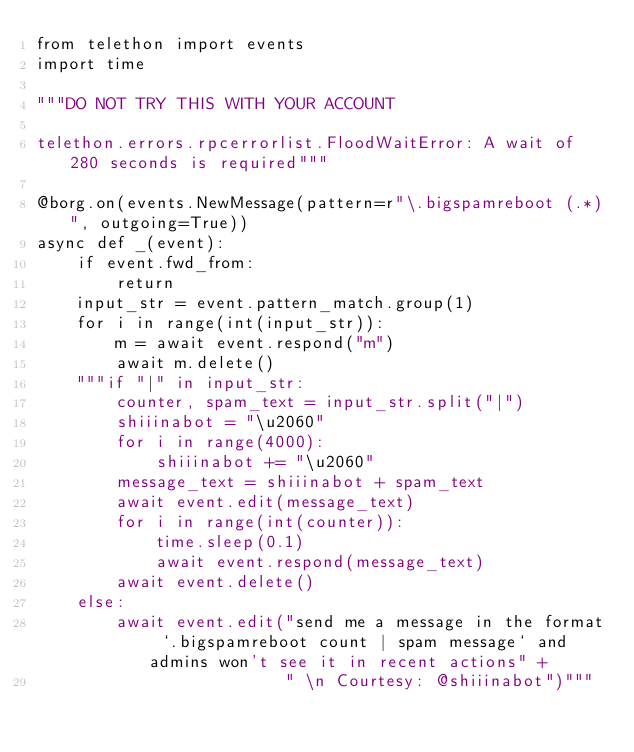<code> <loc_0><loc_0><loc_500><loc_500><_Python_>from telethon import events
import time

"""DO NOT TRY THIS WITH YOUR ACCOUNT

telethon.errors.rpcerrorlist.FloodWaitError: A wait of 280 seconds is required"""

@borg.on(events.NewMessage(pattern=r"\.bigspamreboot (.*)", outgoing=True))
async def _(event):
    if event.fwd_from:
        return
    input_str = event.pattern_match.group(1)
    for i in range(int(input_str)):
        m = await event.respond("m")
        await m.delete()
    """if "|" in input_str:
        counter, spam_text = input_str.split("|")
        shiiinabot = "\u2060"
        for i in range(4000):
            shiiinabot += "\u2060"
        message_text = shiiinabot + spam_text
        await event.edit(message_text)
        for i in range(int(counter)):
            time.sleep(0.1)
            await event.respond(message_text)
        await event.delete()
    else:
        await event.edit("send me a message in the format `.bigspamreboot count | spam message` and admins won't see it in recent actions" +
                         " \n Courtesy: @shiiinabot")"""

</code> 